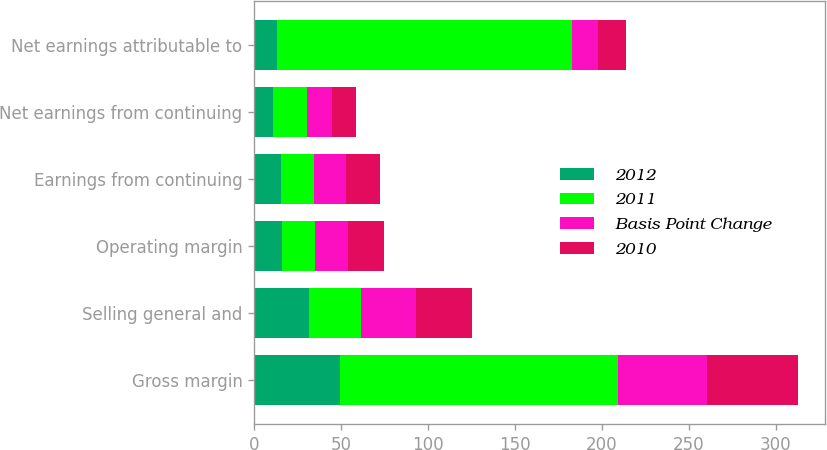Convert chart to OTSL. <chart><loc_0><loc_0><loc_500><loc_500><stacked_bar_chart><ecel><fcel>Gross margin<fcel>Selling general and<fcel>Operating margin<fcel>Earnings from continuing<fcel>Net earnings from continuing<fcel>Net earnings attributable to<nl><fcel>2012<fcel>49.3<fcel>31.5<fcel>15.9<fcel>15.3<fcel>11.1<fcel>12.9<nl><fcel>2011<fcel>160<fcel>30<fcel>19.2<fcel>19.2<fcel>19.2<fcel>170<nl><fcel>Basis Point Change<fcel>50.9<fcel>31.8<fcel>19.1<fcel>18.5<fcel>14.4<fcel>14.6<nl><fcel>2010<fcel>52.3<fcel>32<fcel>20.3<fcel>19.2<fcel>14<fcel>16.4<nl></chart> 